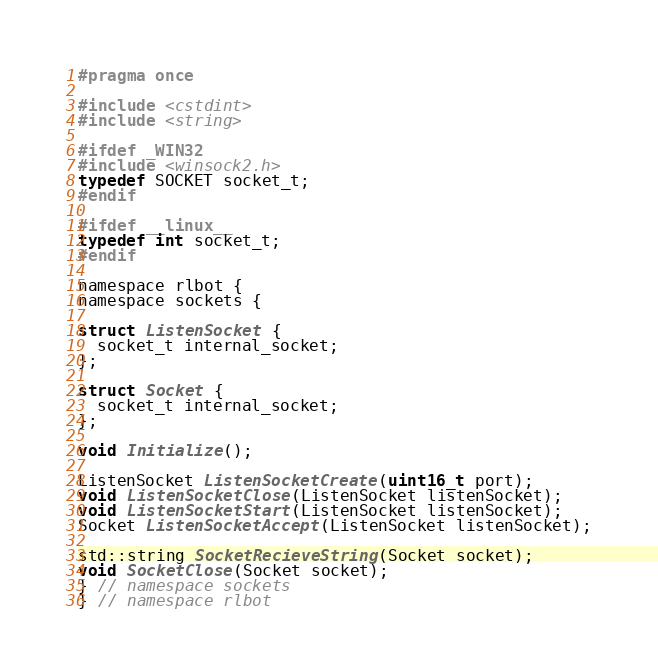Convert code to text. <code><loc_0><loc_0><loc_500><loc_500><_C_>#pragma once

#include <cstdint>
#include <string>

#ifdef _WIN32
#include <winsock2.h>
typedef SOCKET socket_t;
#endif

#ifdef __linux__
typedef int socket_t;
#endif

namespace rlbot {
namespace sockets {

struct ListenSocket {
  socket_t internal_socket;
};

struct Socket {
  socket_t internal_socket;
};

void Initialize();

ListenSocket ListenSocketCreate(uint16_t port);
void ListenSocketClose(ListenSocket listenSocket);
void ListenSocketStart(ListenSocket listenSocket);
Socket ListenSocketAccept(ListenSocket listenSocket);

std::string SocketRecieveString(Socket socket);
void SocketClose(Socket socket);
} // namespace sockets
} // namespace rlbot
</code> 